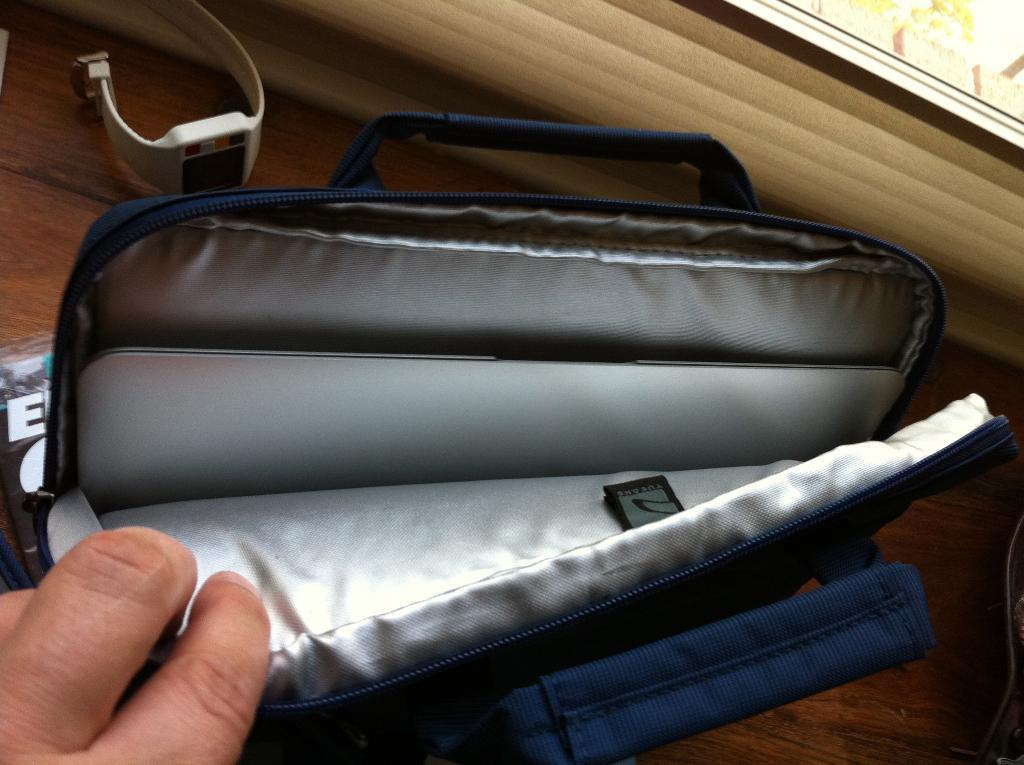Who is present in the image? There is a person in the image. What is the person holding? The person is holding a bag. What object can be seen on the table in the image? There is a watch on a table in the image. What type of vegetation is visible in the background of the image? There is a plant in the background of the image. How does the person measure the distance between the floor and their back in the image? There is no indication in the image that the person is measuring any distance, nor is there any reference to the floor or their back. 